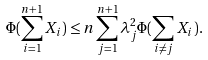<formula> <loc_0><loc_0><loc_500><loc_500>\Phi ( \sum _ { i = 1 } ^ { n + 1 } X _ { i } ) \leq n \sum _ { j = 1 } ^ { n + 1 } \lambda _ { j } ^ { 2 } \Phi ( \sum _ { i \neq j } X _ { i } ) .</formula> 